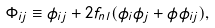Convert formula to latex. <formula><loc_0><loc_0><loc_500><loc_500>\Phi _ { i j } \equiv \phi _ { i j } + 2 f _ { n l } ( \phi _ { i } \phi _ { j } + \phi \phi _ { i j } ) ,</formula> 